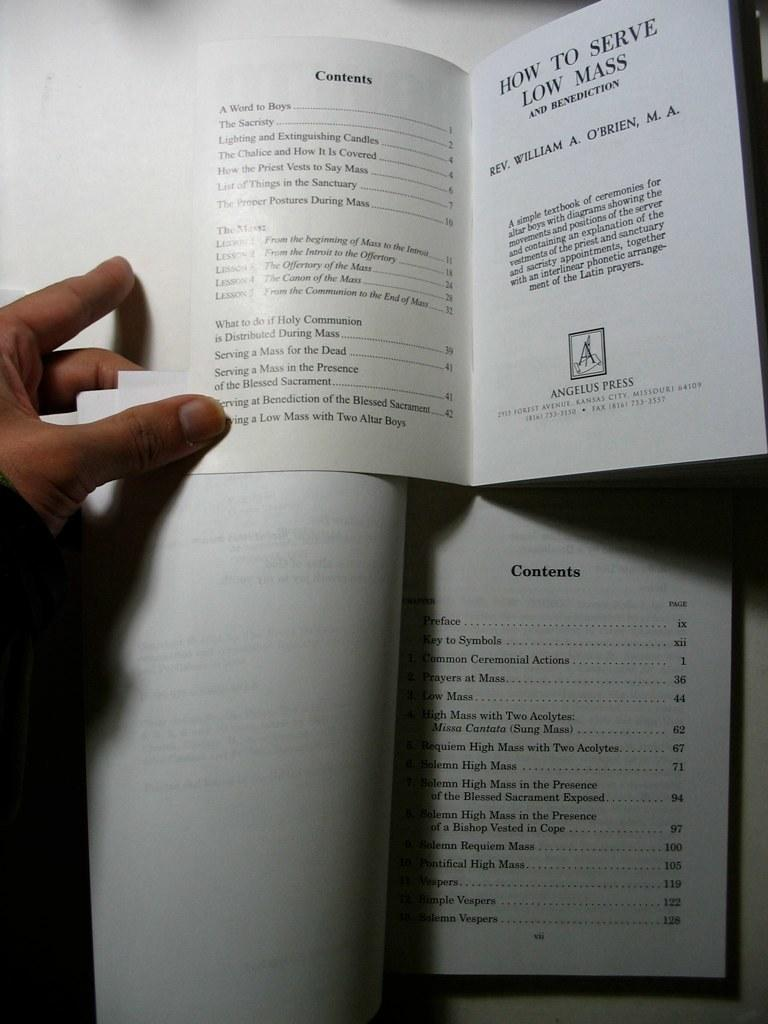<image>
Offer a succinct explanation of the picture presented. An open book and a small open pamphlet laying on top that are both turned to the Contents page. 